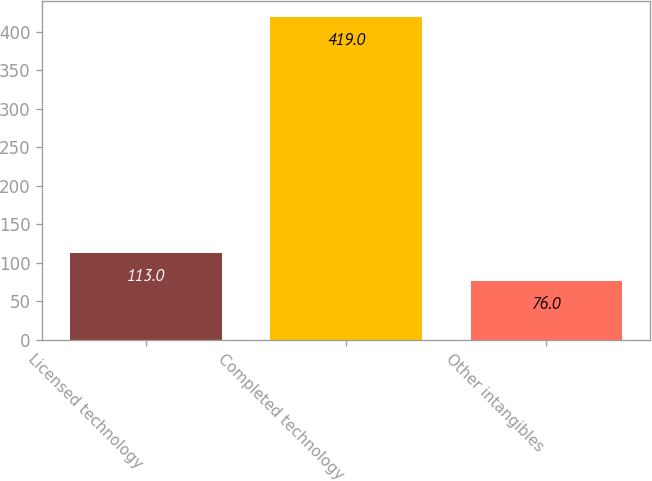Convert chart. <chart><loc_0><loc_0><loc_500><loc_500><bar_chart><fcel>Licensed technology<fcel>Completed technology<fcel>Other intangibles<nl><fcel>113<fcel>419<fcel>76<nl></chart> 